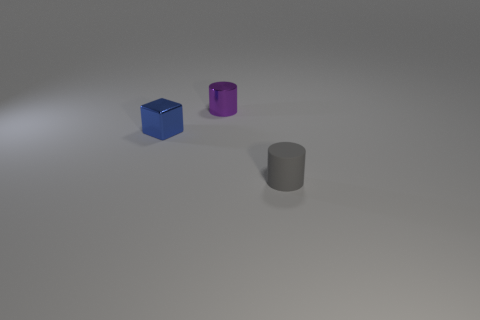Are there any other things that have the same material as the small gray object?
Make the answer very short. No. Is the number of blue metallic objects that are on the right side of the small gray thing greater than the number of tiny brown rubber cylinders?
Give a very brief answer. No. There is a thing that is on the right side of the tiny metallic object that is right of the shiny thing in front of the metal cylinder; what is its color?
Offer a terse response. Gray. Does the tiny blue block have the same material as the tiny purple cylinder?
Provide a succinct answer. Yes. Is there a matte cylinder that has the same size as the blue shiny cube?
Your answer should be compact. Yes. There is a gray object that is the same size as the blue cube; what is its material?
Your response must be concise. Rubber. Is there a gray rubber thing of the same shape as the small purple thing?
Ensure brevity in your answer.  Yes. What is the shape of the object that is in front of the blue metallic thing?
Offer a terse response. Cylinder. What number of small things are there?
Your answer should be very brief. 3. What is the color of the small cylinder that is made of the same material as the small blue thing?
Provide a succinct answer. Purple. 